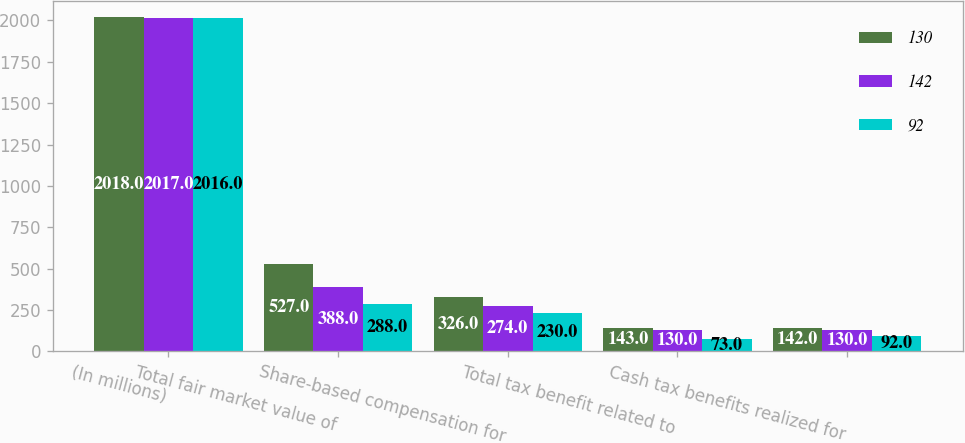<chart> <loc_0><loc_0><loc_500><loc_500><stacked_bar_chart><ecel><fcel>(In millions)<fcel>Total fair market value of<fcel>Share-based compensation for<fcel>Total tax benefit related to<fcel>Cash tax benefits realized for<nl><fcel>130<fcel>2018<fcel>527<fcel>326<fcel>143<fcel>142<nl><fcel>142<fcel>2017<fcel>388<fcel>274<fcel>130<fcel>130<nl><fcel>92<fcel>2016<fcel>288<fcel>230<fcel>73<fcel>92<nl></chart> 